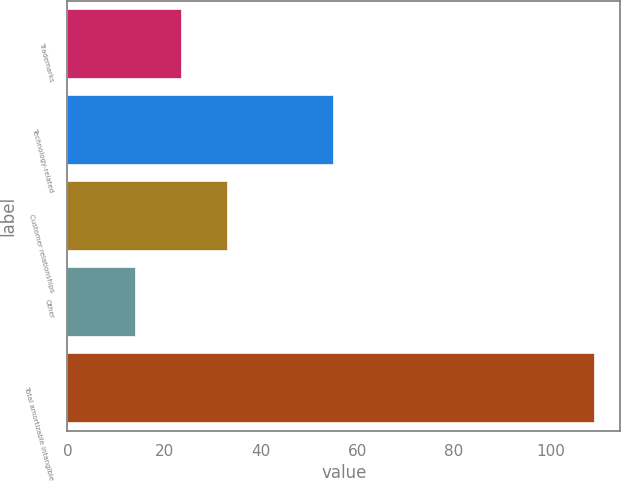Convert chart to OTSL. <chart><loc_0><loc_0><loc_500><loc_500><bar_chart><fcel>Trademarks<fcel>Technology-related<fcel>Customer relationships<fcel>Other<fcel>Total amortizable intangible<nl><fcel>23.5<fcel>55<fcel>33<fcel>14<fcel>109<nl></chart> 